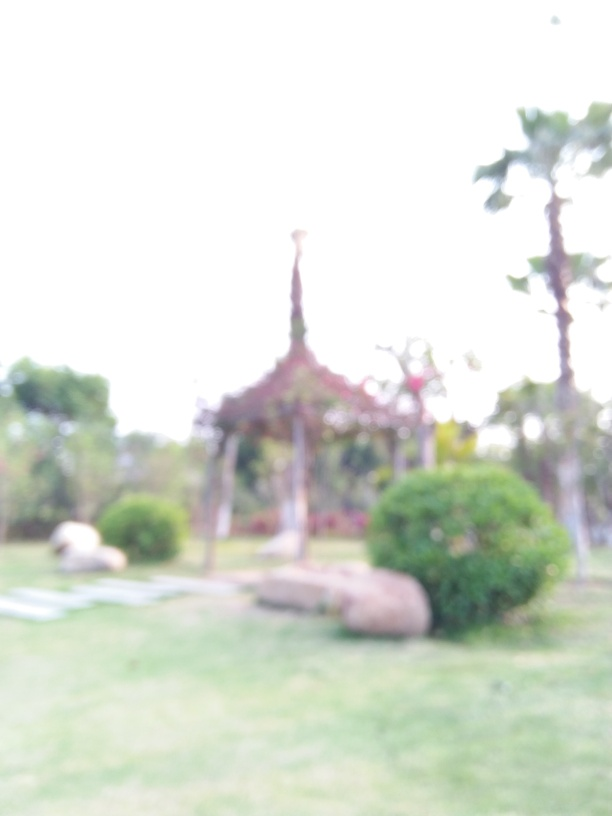What might be the reasons for the poor quality of this image? The poor quality of the image is likely due to a few factors. A primary cause is the lack of focus, making the entire scene appear blurry. This might have resulted from incorrect focus settings on the camera or motion blur if the camera moved while the photo was being taken. It's also possible that a smudged or dirty camera lens contributed to the unclear image. Lastly, the photo could have been taken with a low-resolution camera or undergone excessive digital enlargement, which can reduce image sharpness. 